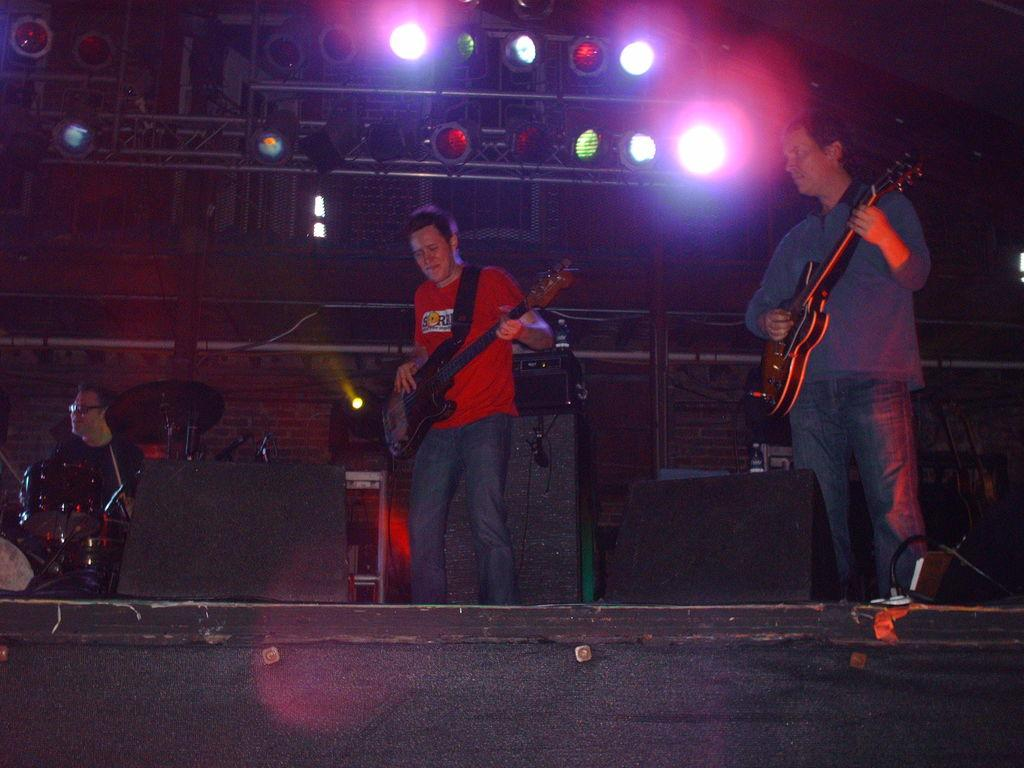What are the two persons on stage doing? The two persons on stage are standing with guitars, which suggests they are musicians or performers. What is the person sitting on stage doing? The person sitting on stage is playing a musical instrument, indicating they are also a musician or performer. What can be seen above the stage? There are focusing lights on top, which are likely used to illuminate the performers during the show. What equipment is present to amplify the sound? There are sound boxes present, which are used to amplify the sound of the musical instruments. What type of maid is visible in the image? There is no maid present in the image; it features musicians on stage. What type of calculator is being used by the person sitting on stage? There is no calculator visible in the image; the person sitting on stage is playing a musical instrument. 